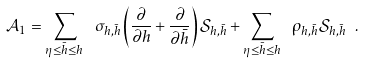Convert formula to latex. <formula><loc_0><loc_0><loc_500><loc_500>\mathcal { A } _ { 1 } = \sum _ { \eta \leq \bar { h } \leq h } \ \sigma _ { h , \bar { h } } \left ( \frac { \partial } { \partial h } + \frac { \partial } { \partial \bar { h } } \right ) \mathcal { S } _ { h , \bar { h } } + \sum _ { \eta \leq \bar { h } \leq h } \ \rho _ { h , \bar { h } } \mathcal { S } _ { h , \bar { h } } \ .</formula> 